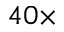Convert formula to latex. <formula><loc_0><loc_0><loc_500><loc_500>4 0 \times</formula> 